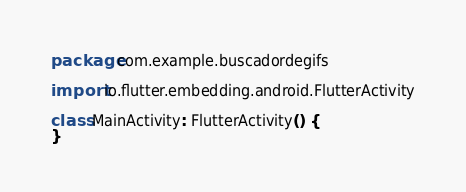<code> <loc_0><loc_0><loc_500><loc_500><_Kotlin_>package com.example.buscadordegifs

import io.flutter.embedding.android.FlutterActivity

class MainActivity: FlutterActivity() {
}
</code> 